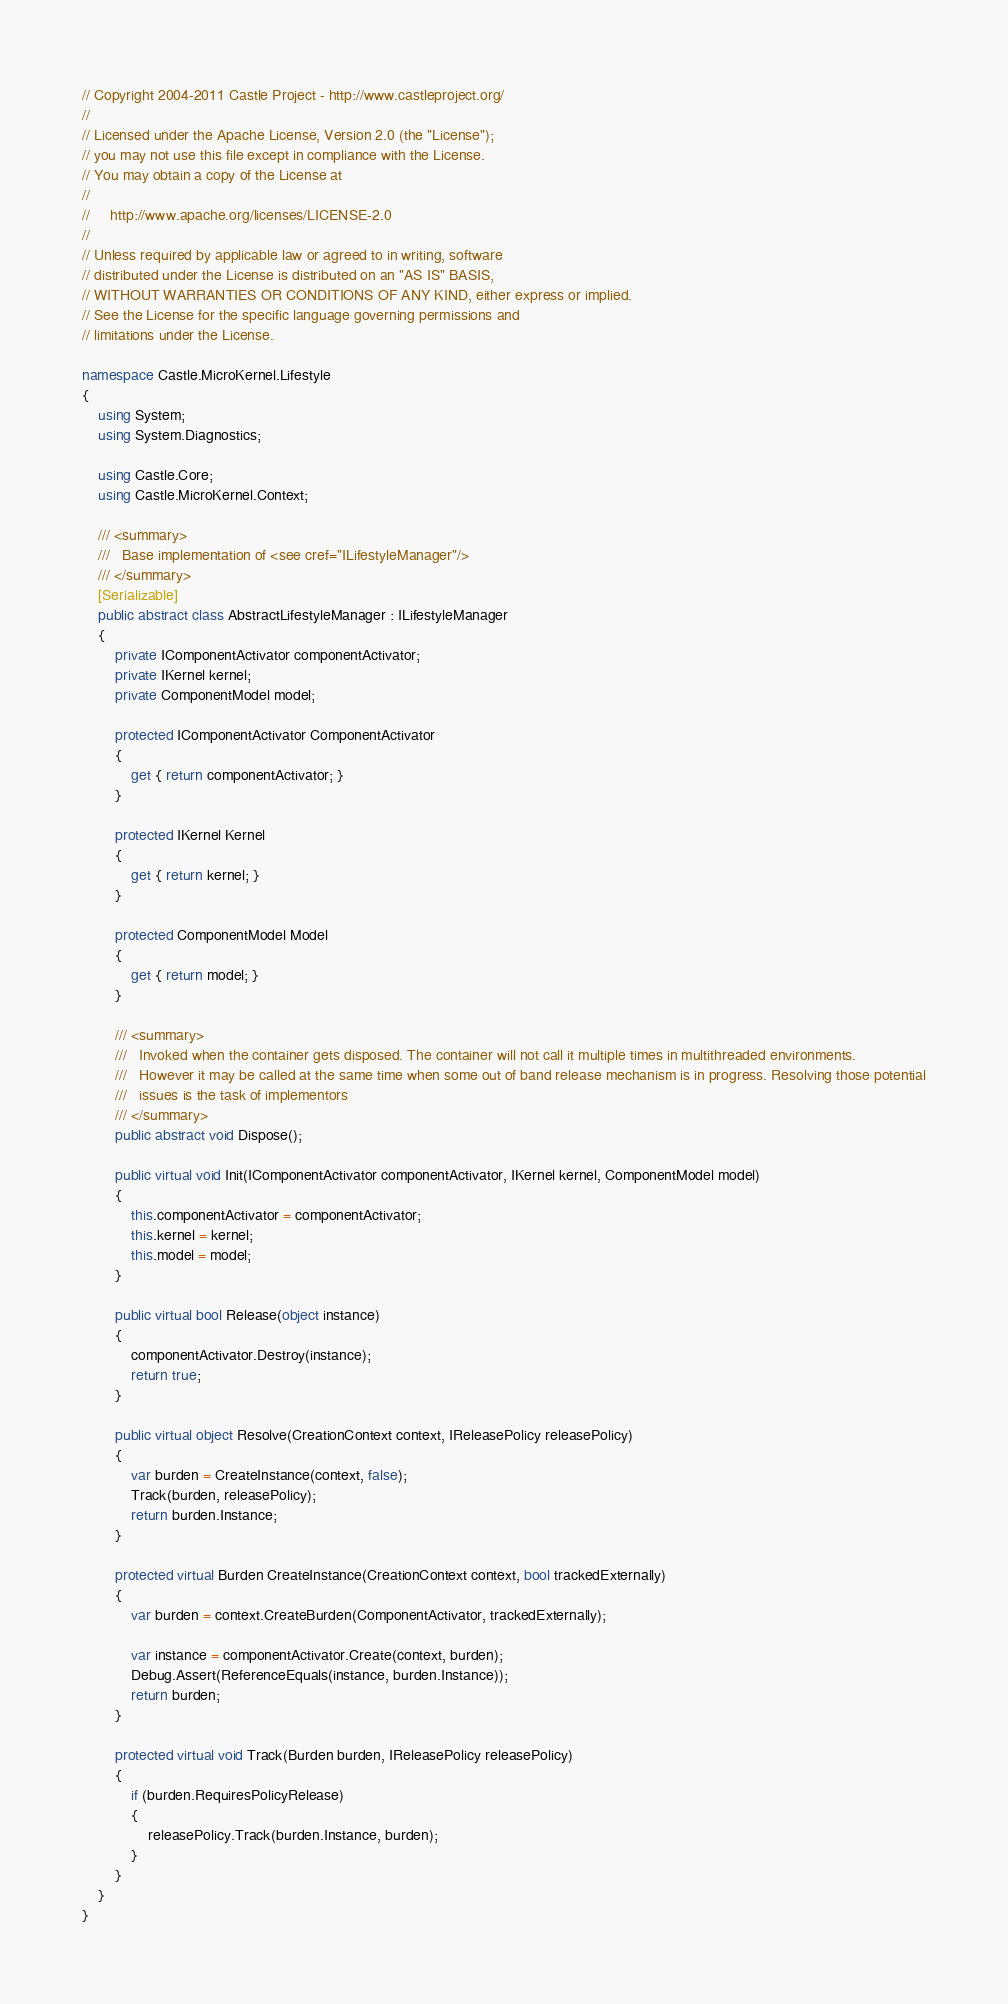Convert code to text. <code><loc_0><loc_0><loc_500><loc_500><_C#_>// Copyright 2004-2011 Castle Project - http://www.castleproject.org/
// 
// Licensed under the Apache License, Version 2.0 (the "License");
// you may not use this file except in compliance with the License.
// You may obtain a copy of the License at
// 
//     http://www.apache.org/licenses/LICENSE-2.0
// 
// Unless required by applicable law or agreed to in writing, software
// distributed under the License is distributed on an "AS IS" BASIS,
// WITHOUT WARRANTIES OR CONDITIONS OF ANY KIND, either express or implied.
// See the License for the specific language governing permissions and
// limitations under the License.

namespace Castle.MicroKernel.Lifestyle
{
	using System;
	using System.Diagnostics;

	using Castle.Core;
	using Castle.MicroKernel.Context;

	/// <summary>
	///   Base implementation of <see cref="ILifestyleManager"/>
	/// </summary>
	[Serializable]
	public abstract class AbstractLifestyleManager : ILifestyleManager
	{
		private IComponentActivator componentActivator;
		private IKernel kernel;
		private ComponentModel model;

		protected IComponentActivator ComponentActivator
		{
			get { return componentActivator; }
		}

		protected IKernel Kernel
		{
			get { return kernel; }
		}

		protected ComponentModel Model
		{
			get { return model; }
		}

		/// <summary>
		///   Invoked when the container gets disposed. The container will not call it multiple times in multithreaded environments.
		///   However it may be called at the same time when some out of band release mechanism is in progress. Resolving those potential
		///   issues is the task of implementors
		/// </summary>
		public abstract void Dispose();

		public virtual void Init(IComponentActivator componentActivator, IKernel kernel, ComponentModel model)
		{
			this.componentActivator = componentActivator;
			this.kernel = kernel;
			this.model = model;
		}

		public virtual bool Release(object instance)
		{
			componentActivator.Destroy(instance);
			return true;
		}

		public virtual object Resolve(CreationContext context, IReleasePolicy releasePolicy)
		{
			var burden = CreateInstance(context, false);
			Track(burden, releasePolicy);
			return burden.Instance;
		}

		protected virtual Burden CreateInstance(CreationContext context, bool trackedExternally)
		{
			var burden = context.CreateBurden(ComponentActivator, trackedExternally);

			var instance = componentActivator.Create(context, burden);
			Debug.Assert(ReferenceEquals(instance, burden.Instance));
			return burden;
		}

		protected virtual void Track(Burden burden, IReleasePolicy releasePolicy)
		{
			if (burden.RequiresPolicyRelease)
			{
				releasePolicy.Track(burden.Instance, burden);
			}
		}
	}
}</code> 